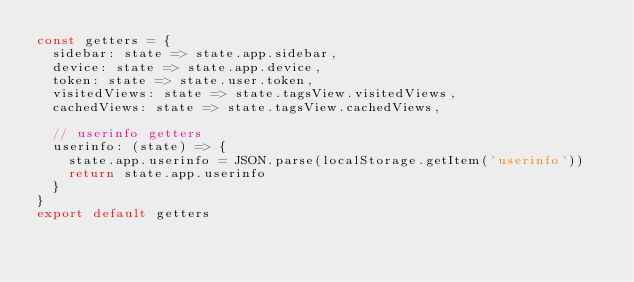<code> <loc_0><loc_0><loc_500><loc_500><_JavaScript_>const getters = {
  sidebar: state => state.app.sidebar,
  device: state => state.app.device,
  token: state => state.user.token,
  visitedViews: state => state.tagsView.visitedViews,
  cachedViews: state => state.tagsView.cachedViews,
  
  // userinfo getters
  userinfo: (state) => {
    state.app.userinfo = JSON.parse(localStorage.getItem('userinfo'))
    return state.app.userinfo
  }
}
export default getters
</code> 